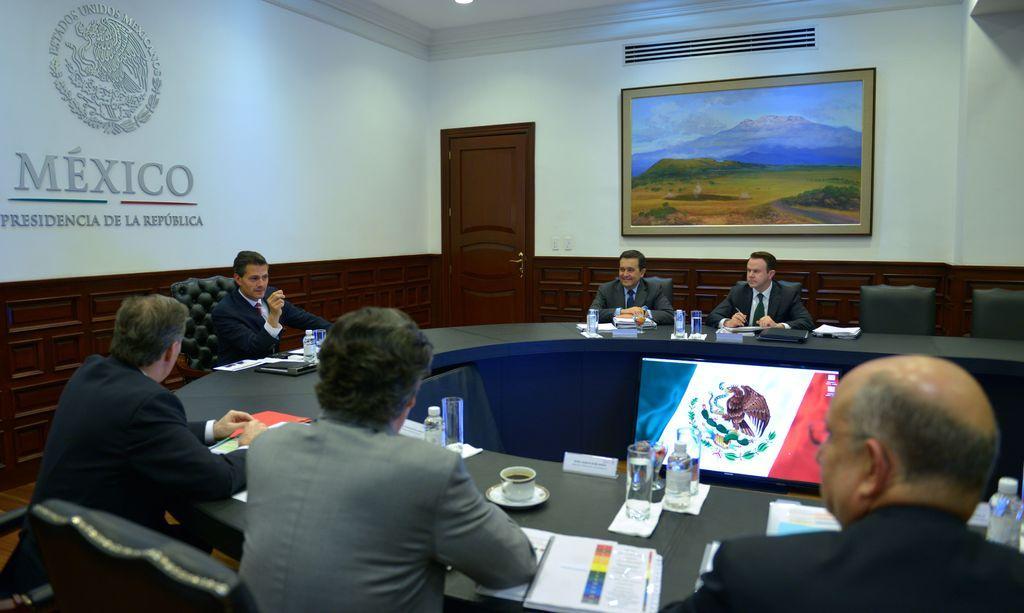Can you describe this image briefly? In this picture there are persons sitting on the chair. In the center there is a table, on the table there are bottles, papers and there is a cup and there is a flag and there are empty chairs. In the background there is some text written on the wall and there is a frame and there is a door. 